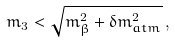<formula> <loc_0><loc_0><loc_500><loc_500>m _ { 3 } < \sqrt { m _ { \beta } ^ { 2 } + \delta m ^ { 2 } _ { a t m } } \, ,</formula> 